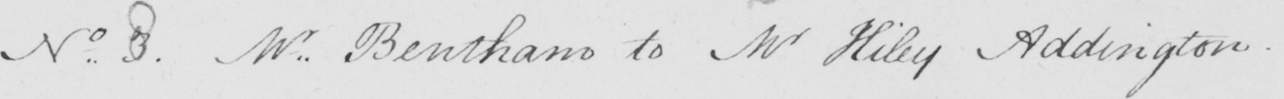What is written in this line of handwriting? No 8 Mr . Bentham to Mr Hiley Addington _ 